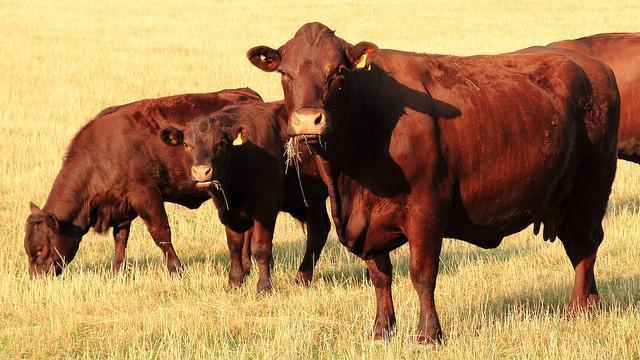How many cows are eating?
Give a very brief answer. 3. How many cows are in the photo?
Give a very brief answer. 4. 